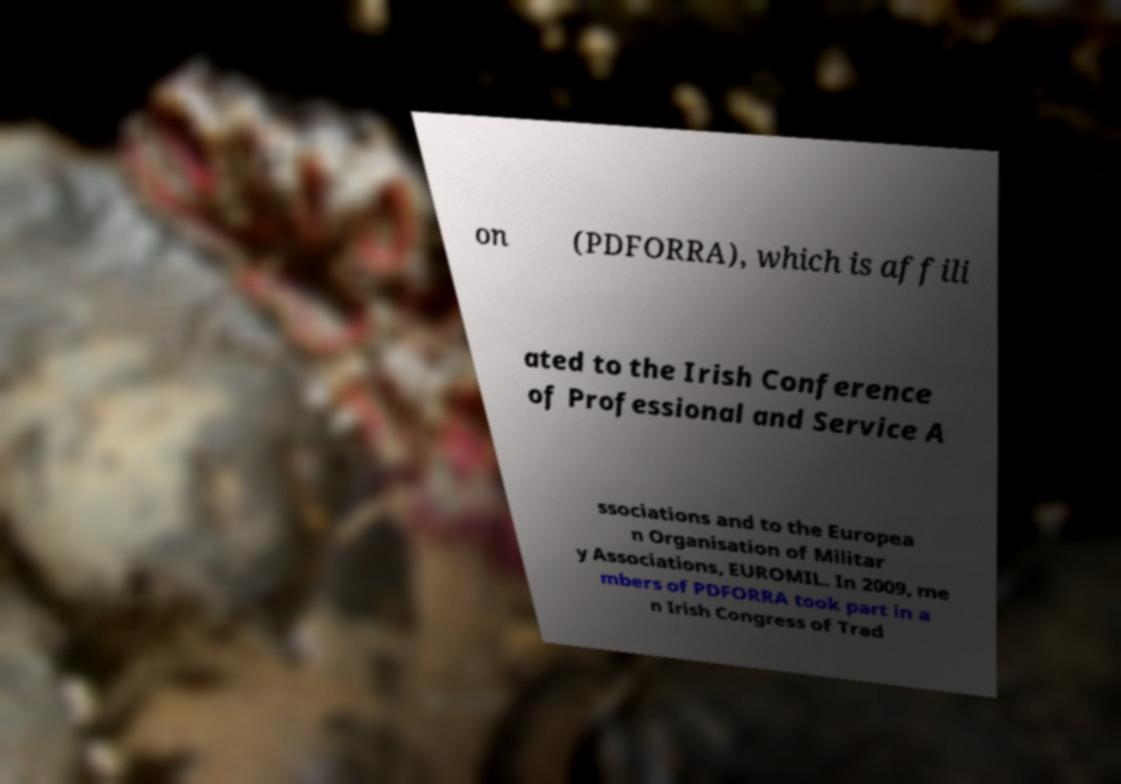Could you assist in decoding the text presented in this image and type it out clearly? on (PDFORRA), which is affili ated to the Irish Conference of Professional and Service A ssociations and to the Europea n Organisation of Militar y Associations, EUROMIL. In 2009, me mbers of PDFORRA took part in a n Irish Congress of Trad 